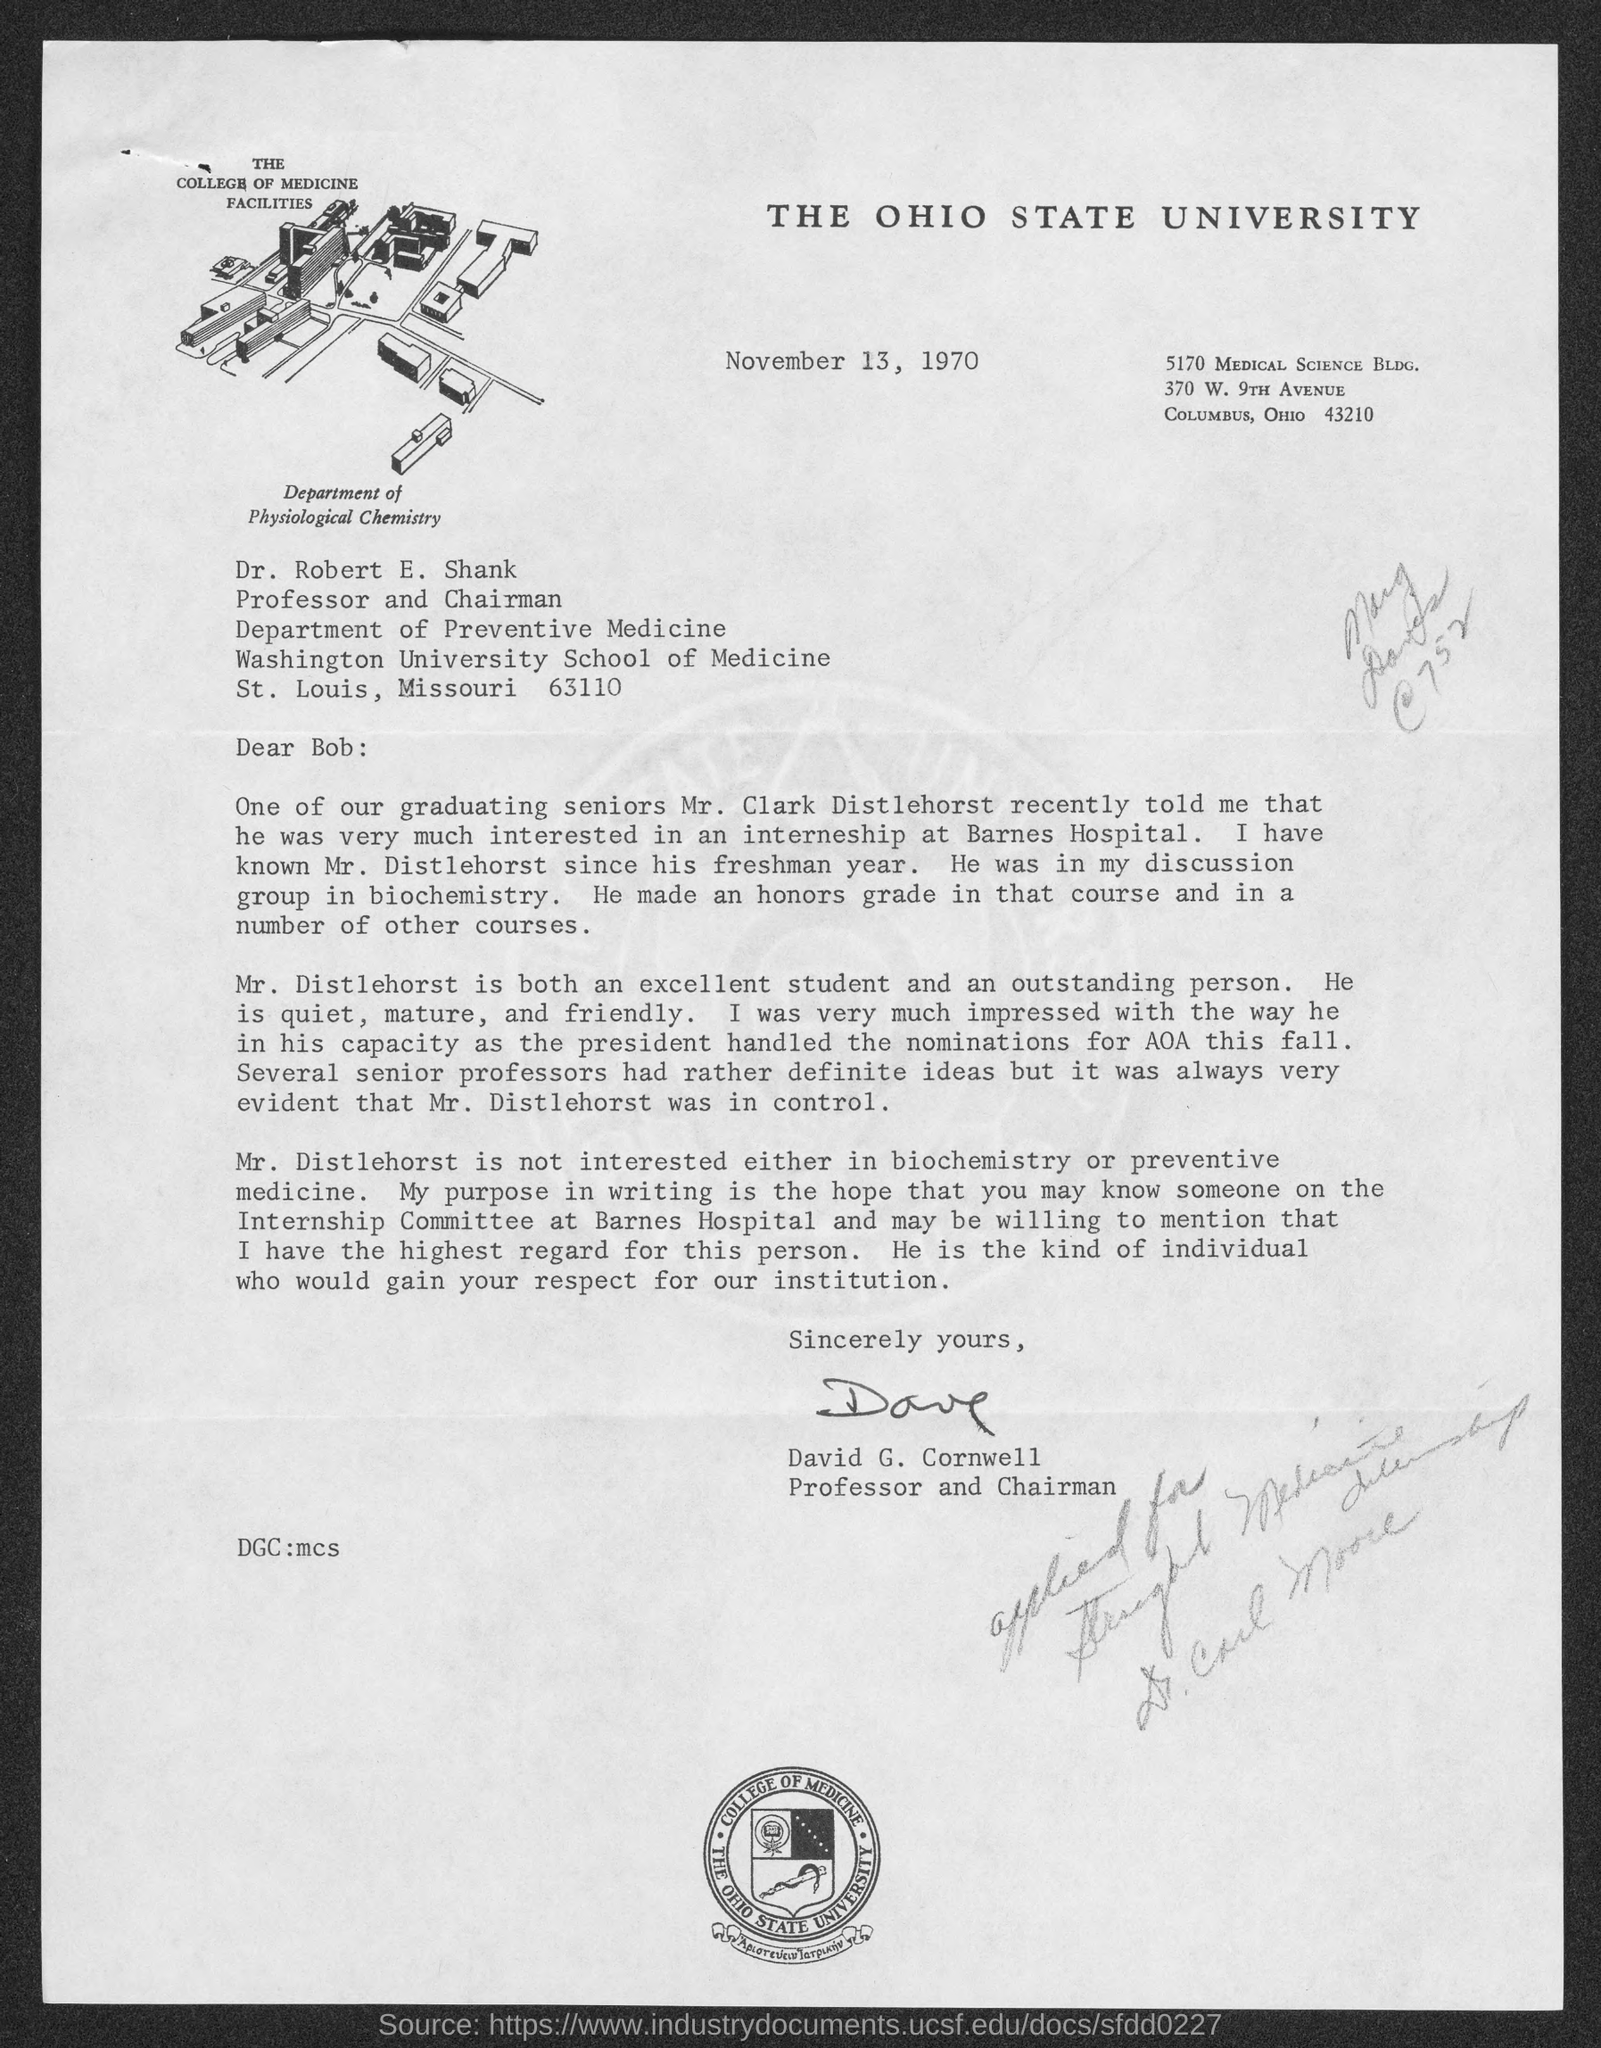Indicate a few pertinent items in this graphic. The date mentioned in the document is November 13, 1970. The title of the document is THE OHIO STATE UNIVERSITY. 